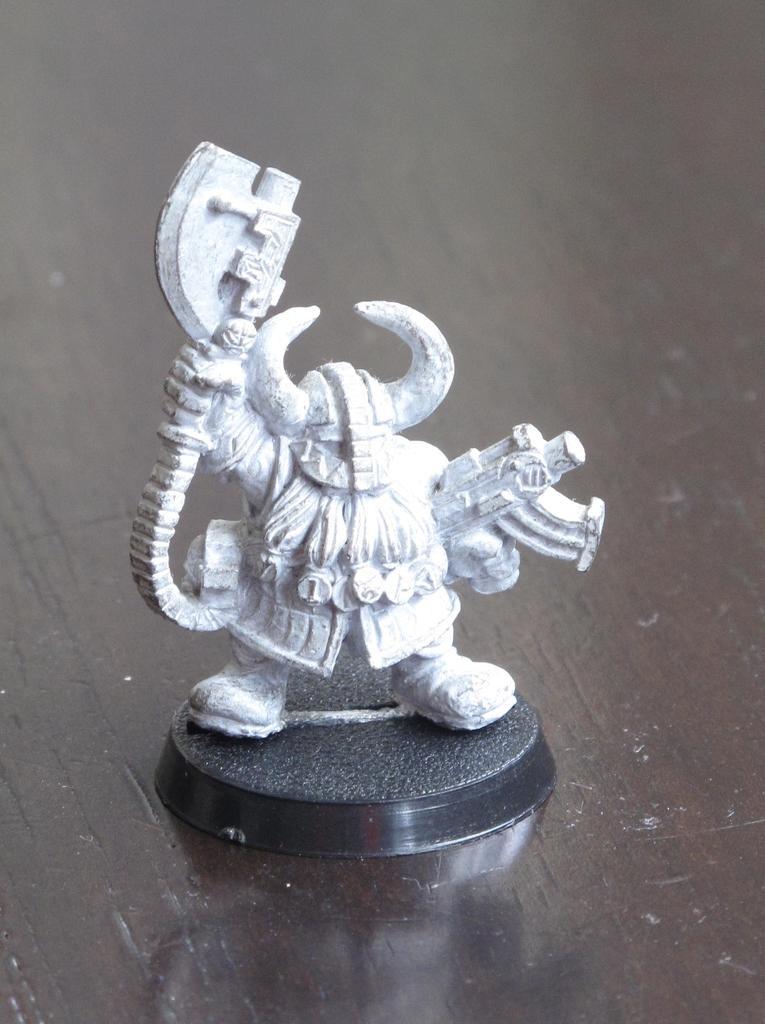Describe this image in one or two sentences. This image consists of a statue. It is small in size. It looks like a toy. 